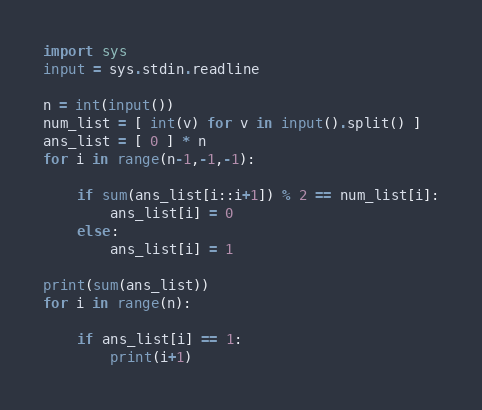Convert code to text. <code><loc_0><loc_0><loc_500><loc_500><_Python_>import sys
input = sys.stdin.readline
 
n = int(input())
num_list = [ int(v) for v in input().split() ]
ans_list = [ 0 ] * n
for i in range(n-1,-1,-1):
 
    if sum(ans_list[i::i+1]) % 2 == num_list[i]:
        ans_list[i] = 0
    else:
        ans_list[i] = 1
 
print(sum(ans_list))
for i in range(n):
 
    if ans_list[i] == 1:
        print(i+1)
</code> 